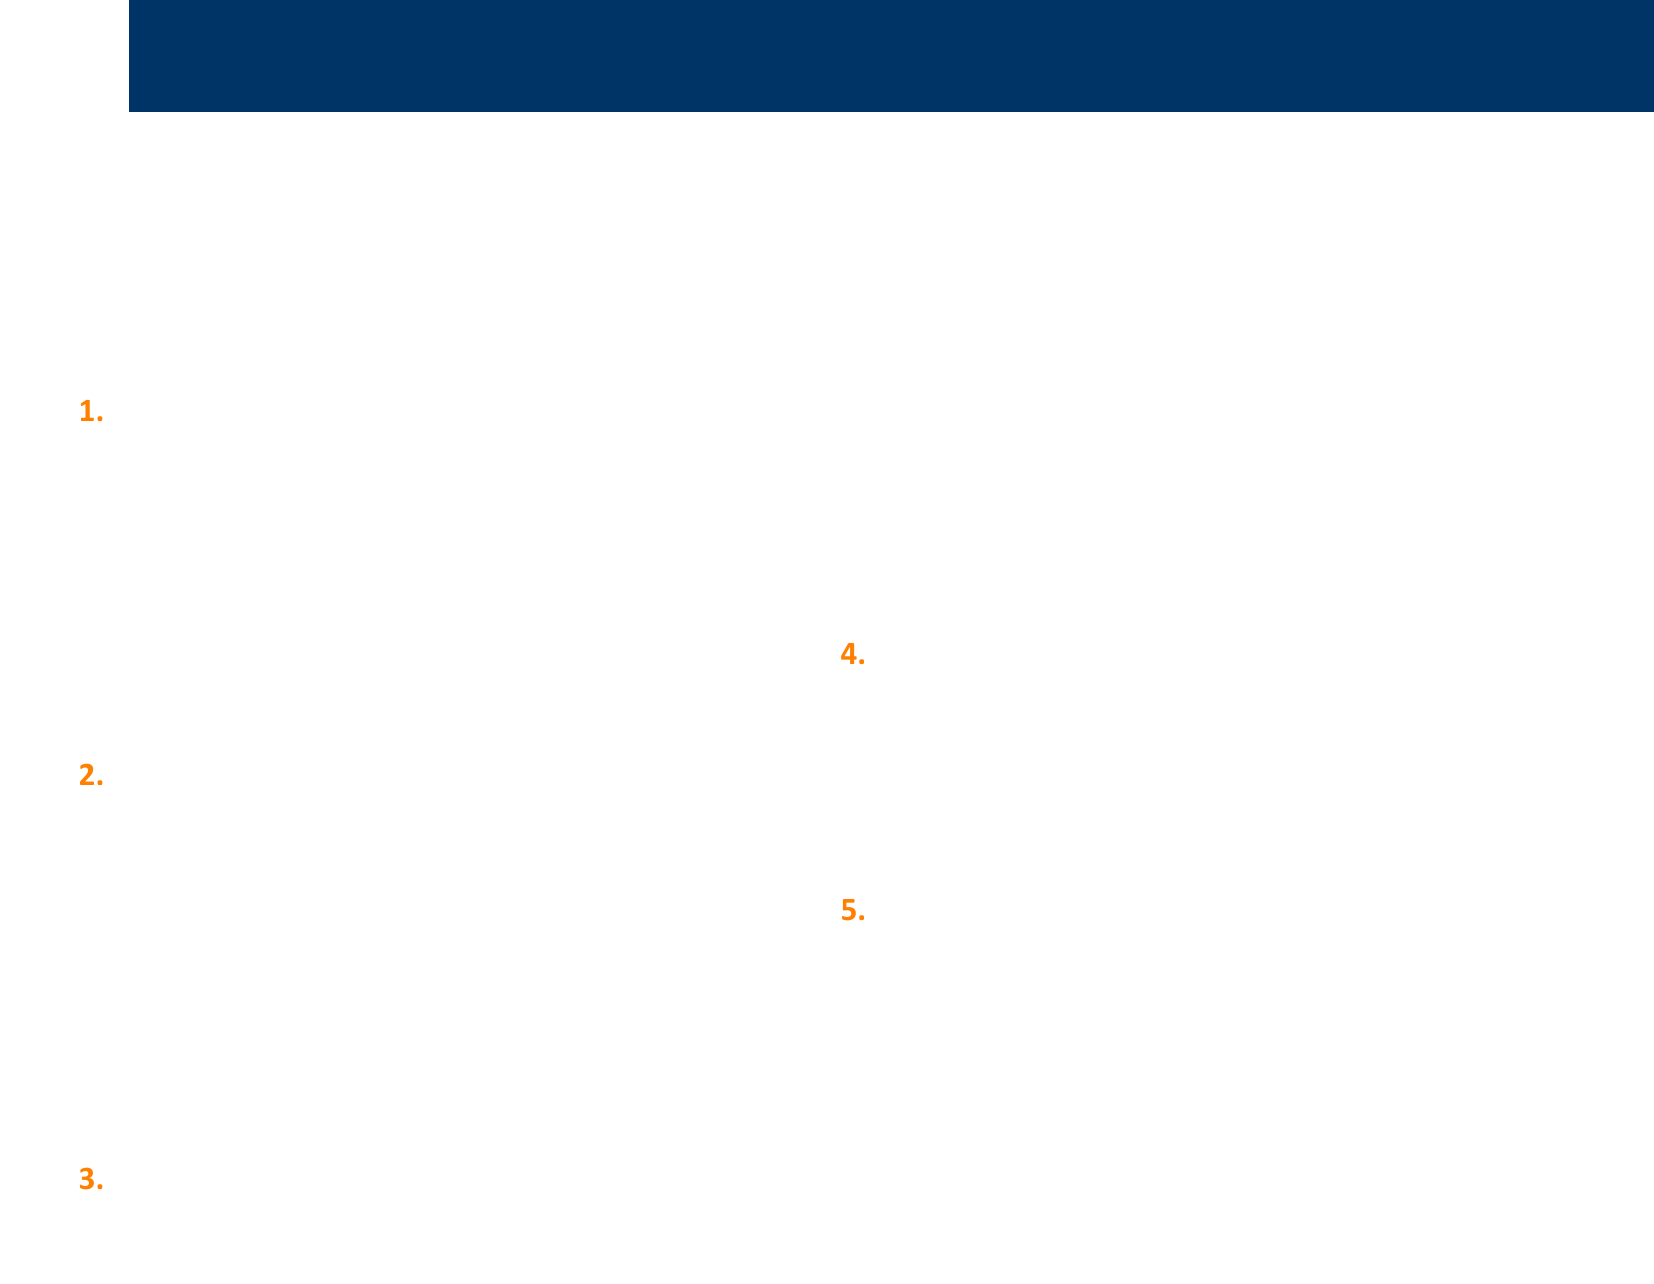what is the title of the document? The title is explicitly stated at the beginning of the document, identifying the main focus of the notes.
Answer: Non-Violent Conflict Resolution Techniques how many techniques are listed? The document enumerates the different non-violent conflict resolution techniques provided within it.
Answer: Five what is the first technique mentioned? The first technique is identified in the list format of the document, revealing the initial approach discussed.
Answer: Active Listening which technique involves using statements that begin with "I feel..."? This specific phrasing is associated with a particular method aimed at expressing personal feelings without blame.
Answer: I-Messages who developed Nonviolent Communication (NVC)? The document attributes the creation of this communication approach to a well-known advocate, giving credit to its origin.
Answer: Marshall Rosenberg what is the main goal of employing these techniques? The conclusion summarizes the overarching aim of applying these conflict resolution strategies presented in the document.
Answer: Promote understanding in what situation might mediation be suggested? The document includes an example of a context where involving a neutral party could facilitate resolution.
Answer: Community disputes over local gun regulations which technique should be used to address concerns without aggression? This method emphasizes addressing issues compassionately, aligning with the theme of the document.
Answer: Nonviolent Communication (NVC) 